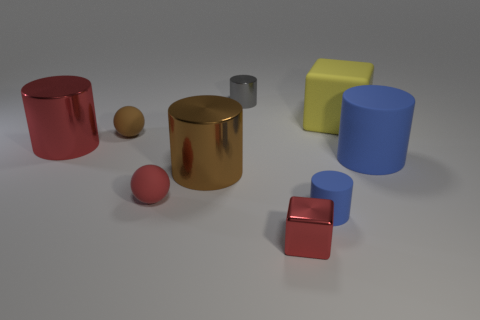There is a small metallic block; is its color the same as the cylinder that is on the left side of the big brown metal object?
Make the answer very short. Yes. How many objects are either shiny cylinders that are behind the matte block or rubber objects?
Make the answer very short. 6. What number of other things are there of the same color as the tiny metallic cylinder?
Make the answer very short. 0. Are there the same number of large metal cylinders that are on the left side of the gray metallic object and yellow matte cubes?
Make the answer very short. No. There is a brown thing behind the blue object on the right side of the yellow cube; how many tiny cubes are on the left side of it?
Your answer should be compact. 0. Is there any other thing that is the same size as the brown sphere?
Offer a very short reply. Yes. Does the rubber block have the same size as the brown object in front of the red metal cylinder?
Offer a very short reply. Yes. How many small metal blocks are there?
Keep it short and to the point. 1. There is a red object that is behind the large blue rubber cylinder; is it the same size as the blue rubber cylinder in front of the tiny red rubber thing?
Offer a terse response. No. What color is the small metal thing that is the same shape as the big brown thing?
Your answer should be compact. Gray. 